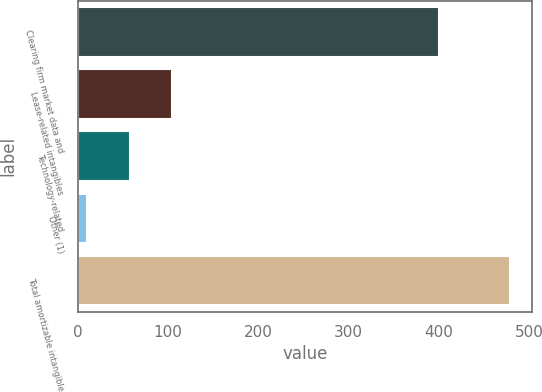Convert chart to OTSL. <chart><loc_0><loc_0><loc_500><loc_500><bar_chart><fcel>Clearing firm market data and<fcel>Lease-related intangibles<fcel>Technology-related<fcel>Other (1)<fcel>Total amortizable intangible<nl><fcel>400.4<fcel>104.26<fcel>57.43<fcel>10.6<fcel>478.9<nl></chart> 